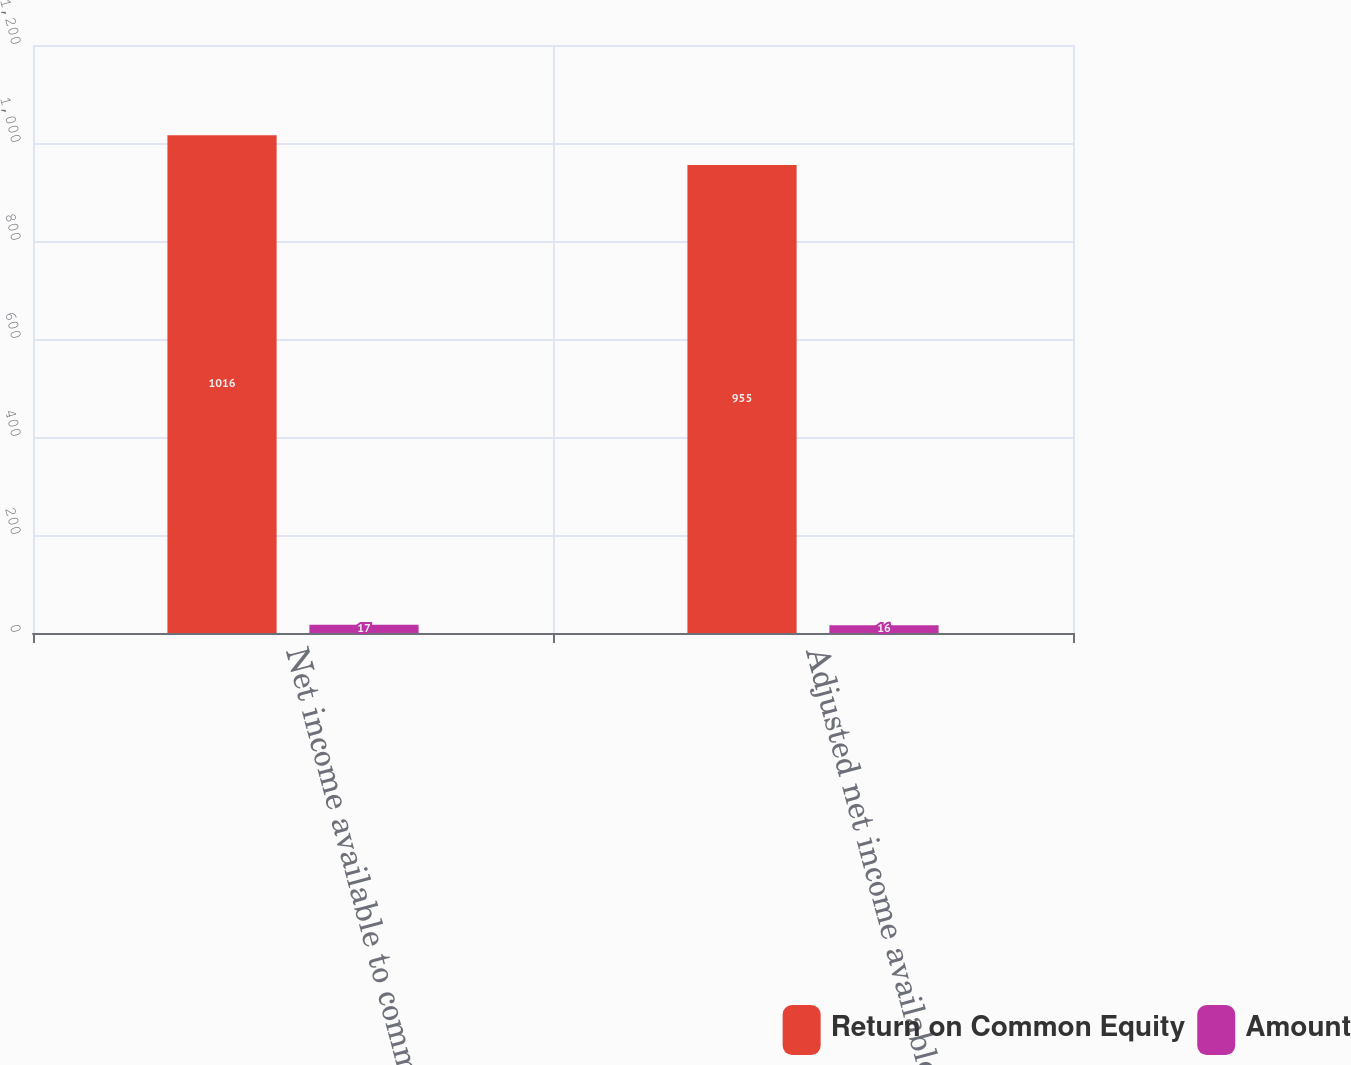<chart> <loc_0><loc_0><loc_500><loc_500><stacked_bar_chart><ecel><fcel>Net income available to common<fcel>Adjusted net income available<nl><fcel>Return on Common Equity<fcel>1016<fcel>955<nl><fcel>Amount<fcel>17<fcel>16<nl></chart> 